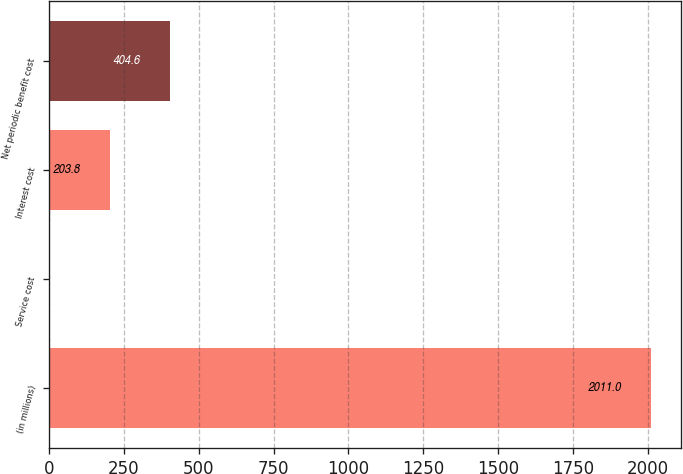Convert chart to OTSL. <chart><loc_0><loc_0><loc_500><loc_500><bar_chart><fcel>(in millions)<fcel>Service cost<fcel>Interest cost<fcel>Net periodic benefit cost<nl><fcel>2011<fcel>3<fcel>203.8<fcel>404.6<nl></chart> 